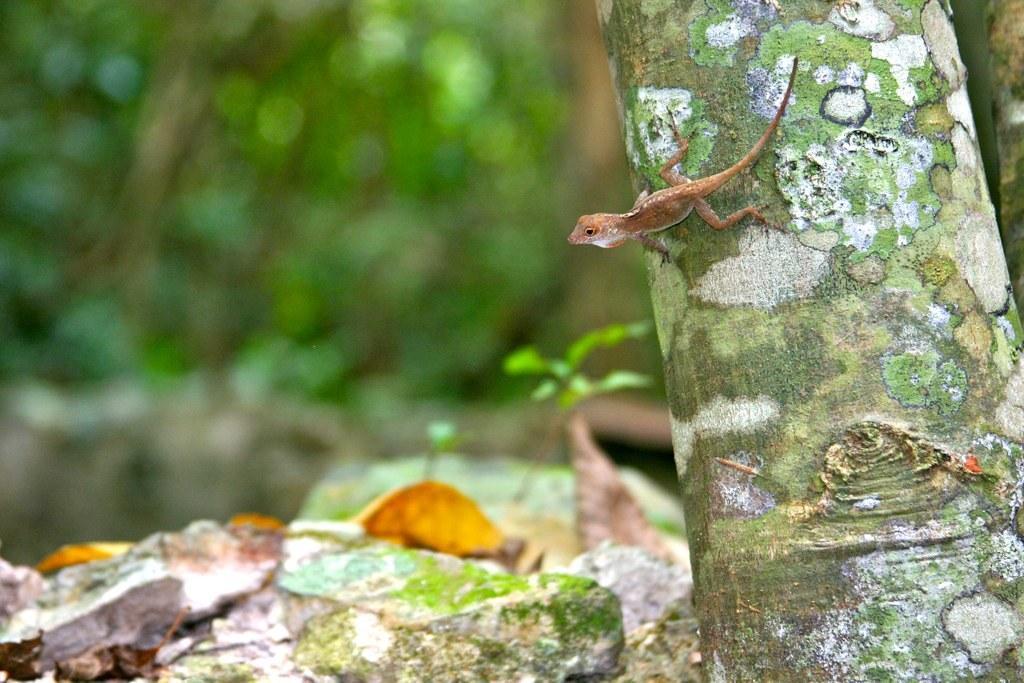Can you describe this image briefly? In this image we can see a lizard on the trunk of a tree, there are rocks, plants, and the background is blurred. 